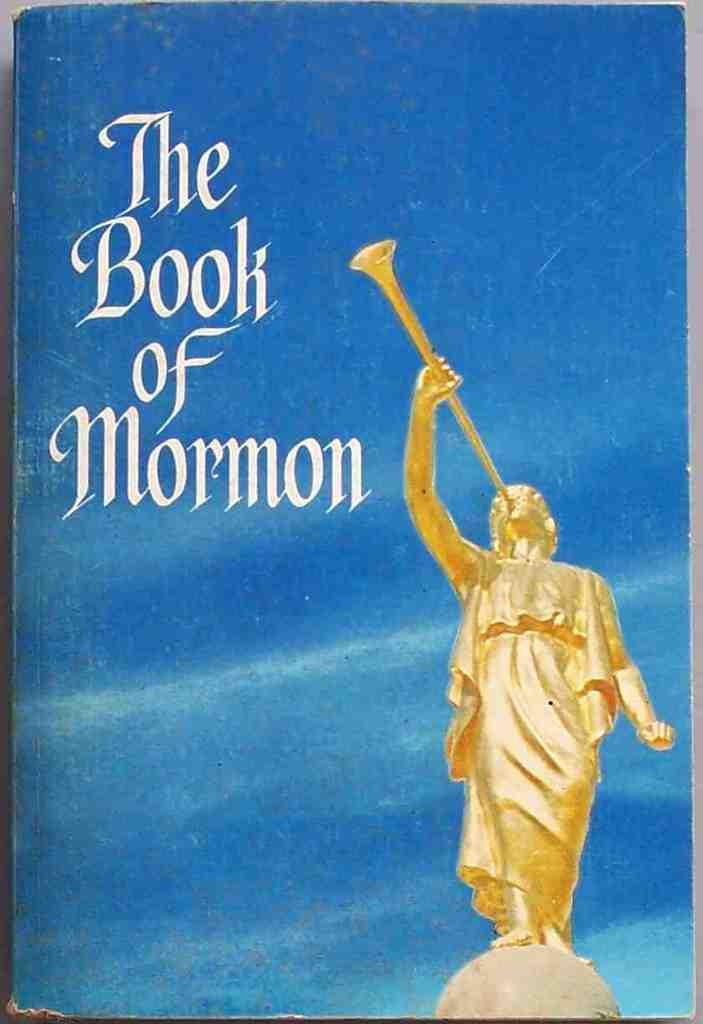<image>
Share a concise interpretation of the image provided. front of the book of mormom which shows blue sky and a gold statue blowing a horn 